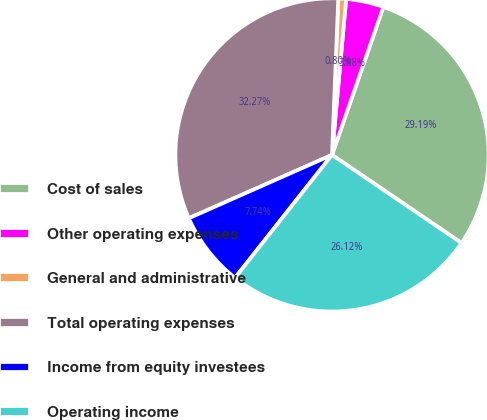<chart> <loc_0><loc_0><loc_500><loc_500><pie_chart><fcel>Cost of sales<fcel>Other operating expenses<fcel>General and administrative<fcel>Total operating expenses<fcel>Income from equity investees<fcel>Operating income<nl><fcel>29.19%<fcel>3.88%<fcel>0.8%<fcel>32.27%<fcel>7.74%<fcel>26.12%<nl></chart> 